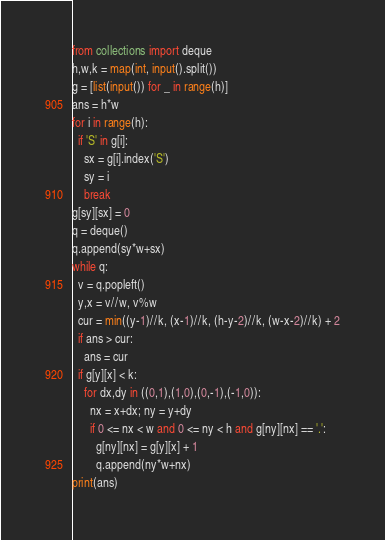Convert code to text. <code><loc_0><loc_0><loc_500><loc_500><_Python_>from collections import deque
h,w,k = map(int, input().split())
g = [list(input()) for _ in range(h)]
ans = h*w
for i in range(h):
  if 'S' in g[i]:
    sx = g[i].index('S')
    sy = i
    break
g[sy][sx] = 0
q = deque()
q.append(sy*w+sx)
while q:
  v = q.popleft()
  y,x = v//w, v%w
  cur = min((y-1)//k, (x-1)//k, (h-y-2)//k, (w-x-2)//k) + 2
  if ans > cur:
    ans = cur
  if g[y][x] < k:
    for dx,dy in ((0,1),(1,0),(0,-1),(-1,0)):
      nx = x+dx; ny = y+dy
      if 0 <= nx < w and 0 <= ny < h and g[ny][nx] == '.':
        g[ny][nx] = g[y][x] + 1
        q.append(ny*w+nx)
print(ans)</code> 